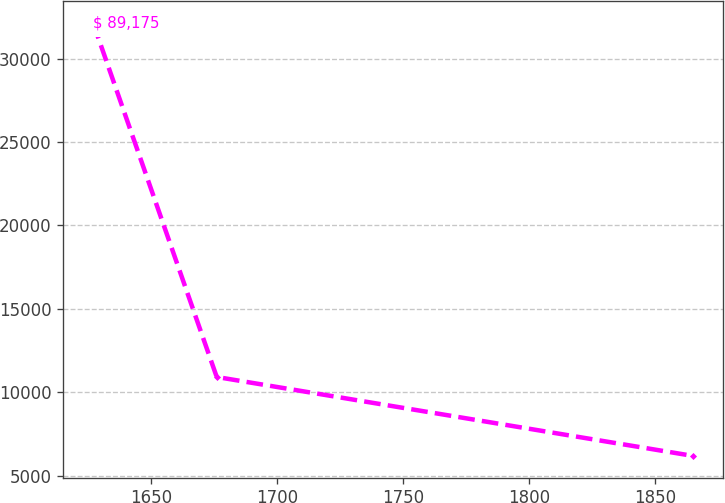Convert chart to OTSL. <chart><loc_0><loc_0><loc_500><loc_500><line_chart><ecel><fcel>$ 89,175<nl><fcel>1626.78<fcel>32149.3<nl><fcel>1675.91<fcel>10912.9<nl><fcel>1864.99<fcel>6181.93<nl></chart> 